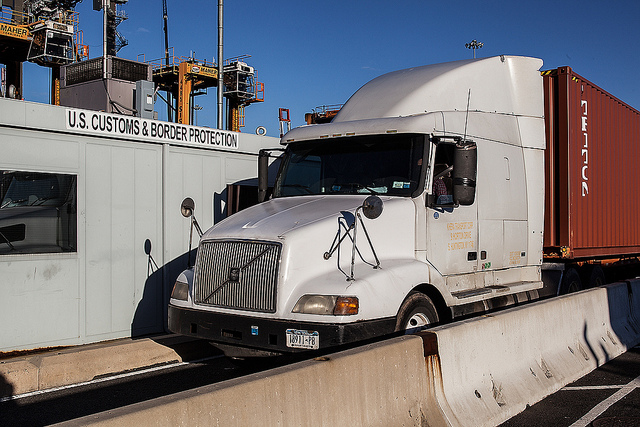How do drivers prepare for inspections at a border booth like the one shown? Drivers must ensure all necessary documentation for themselves and their cargo is readily available for inspection. This includes transport logs, cargo manifests, and any required permits. They also need to adhere to safety protocols, such as turning off the engine during the inspection, and be prepared for possible physical inspections of the cargo container. 